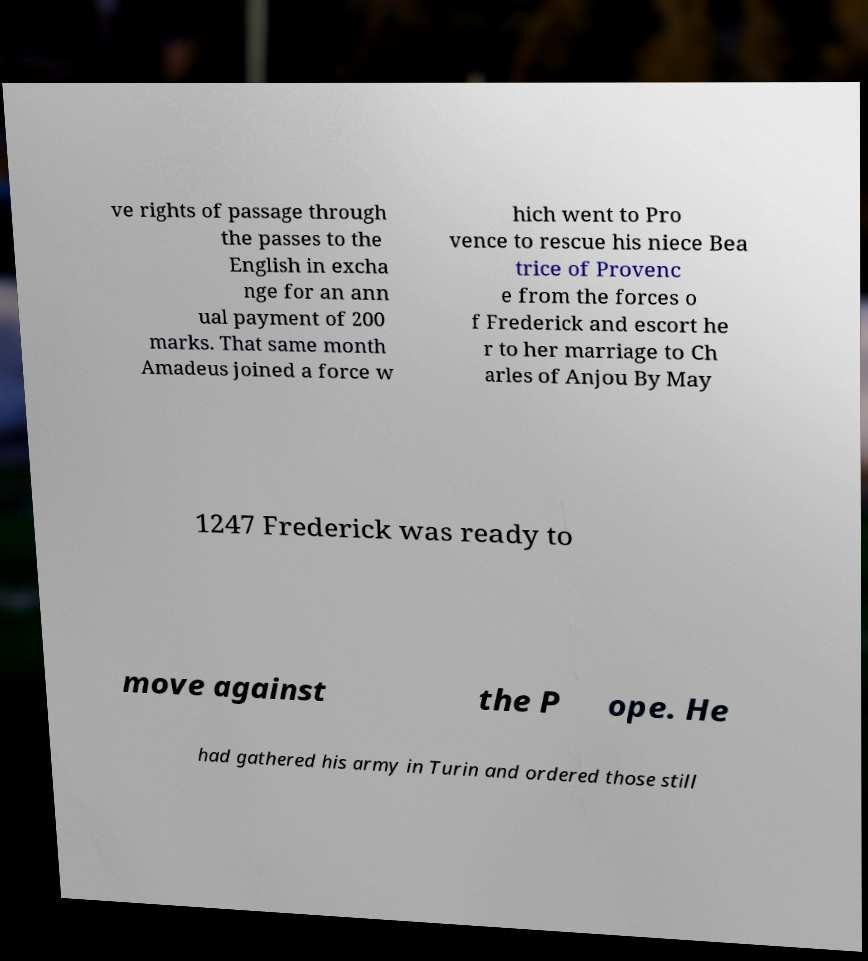Could you assist in decoding the text presented in this image and type it out clearly? ve rights of passage through the passes to the English in excha nge for an ann ual payment of 200 marks. That same month Amadeus joined a force w hich went to Pro vence to rescue his niece Bea trice of Provenc e from the forces o f Frederick and escort he r to her marriage to Ch arles of Anjou By May 1247 Frederick was ready to move against the P ope. He had gathered his army in Turin and ordered those still 